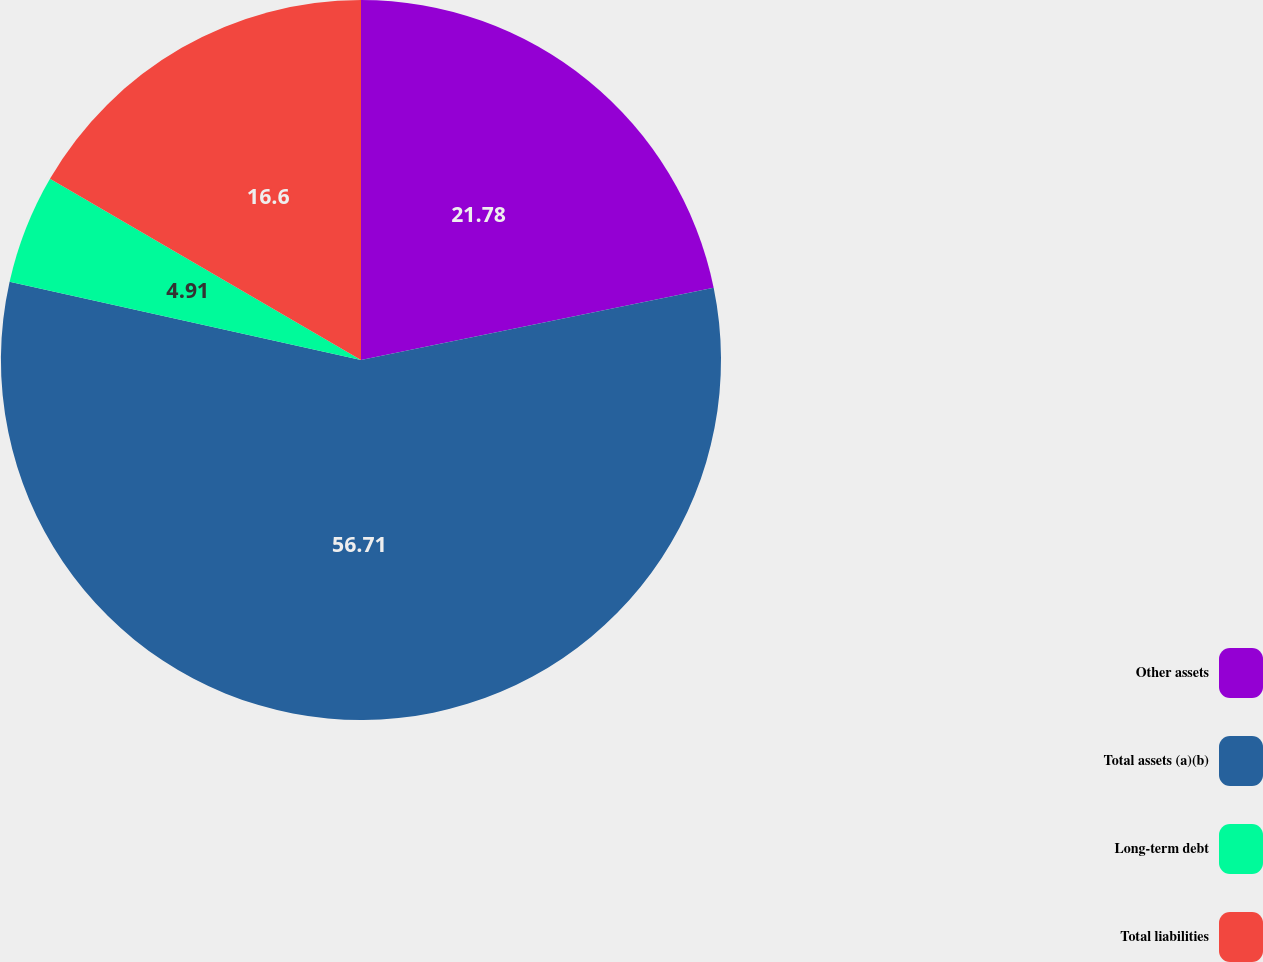Convert chart. <chart><loc_0><loc_0><loc_500><loc_500><pie_chart><fcel>Other assets<fcel>Total assets (a)(b)<fcel>Long-term debt<fcel>Total liabilities<nl><fcel>21.78%<fcel>56.71%<fcel>4.91%<fcel>16.6%<nl></chart> 